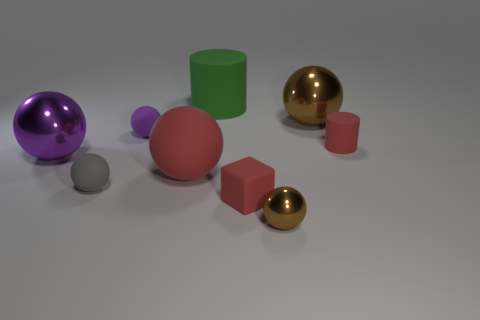Are there fewer purple matte things that are in front of the tiny cube than large brown balls?
Provide a succinct answer. Yes. How many purple metallic spheres are the same size as the red sphere?
Keep it short and to the point. 1. There is a object that is the same color as the small metal ball; what shape is it?
Your answer should be very brief. Sphere. Do the large sphere on the right side of the red rubber ball and the metallic sphere on the left side of the small cube have the same color?
Make the answer very short. No. What number of things are to the right of the green matte cylinder?
Provide a succinct answer. 4. What is the size of the ball that is the same color as the tiny cylinder?
Provide a succinct answer. Large. Is there a brown metal thing that has the same shape as the purple shiny thing?
Offer a very short reply. Yes. There is a matte thing that is the same size as the green cylinder; what is its color?
Your response must be concise. Red. Are there fewer green matte cylinders that are on the right side of the purple rubber object than red matte objects that are right of the tiny cube?
Your answer should be very brief. No. There is a brown metal thing that is behind the purple matte thing; is it the same size as the large purple thing?
Provide a short and direct response. Yes. 